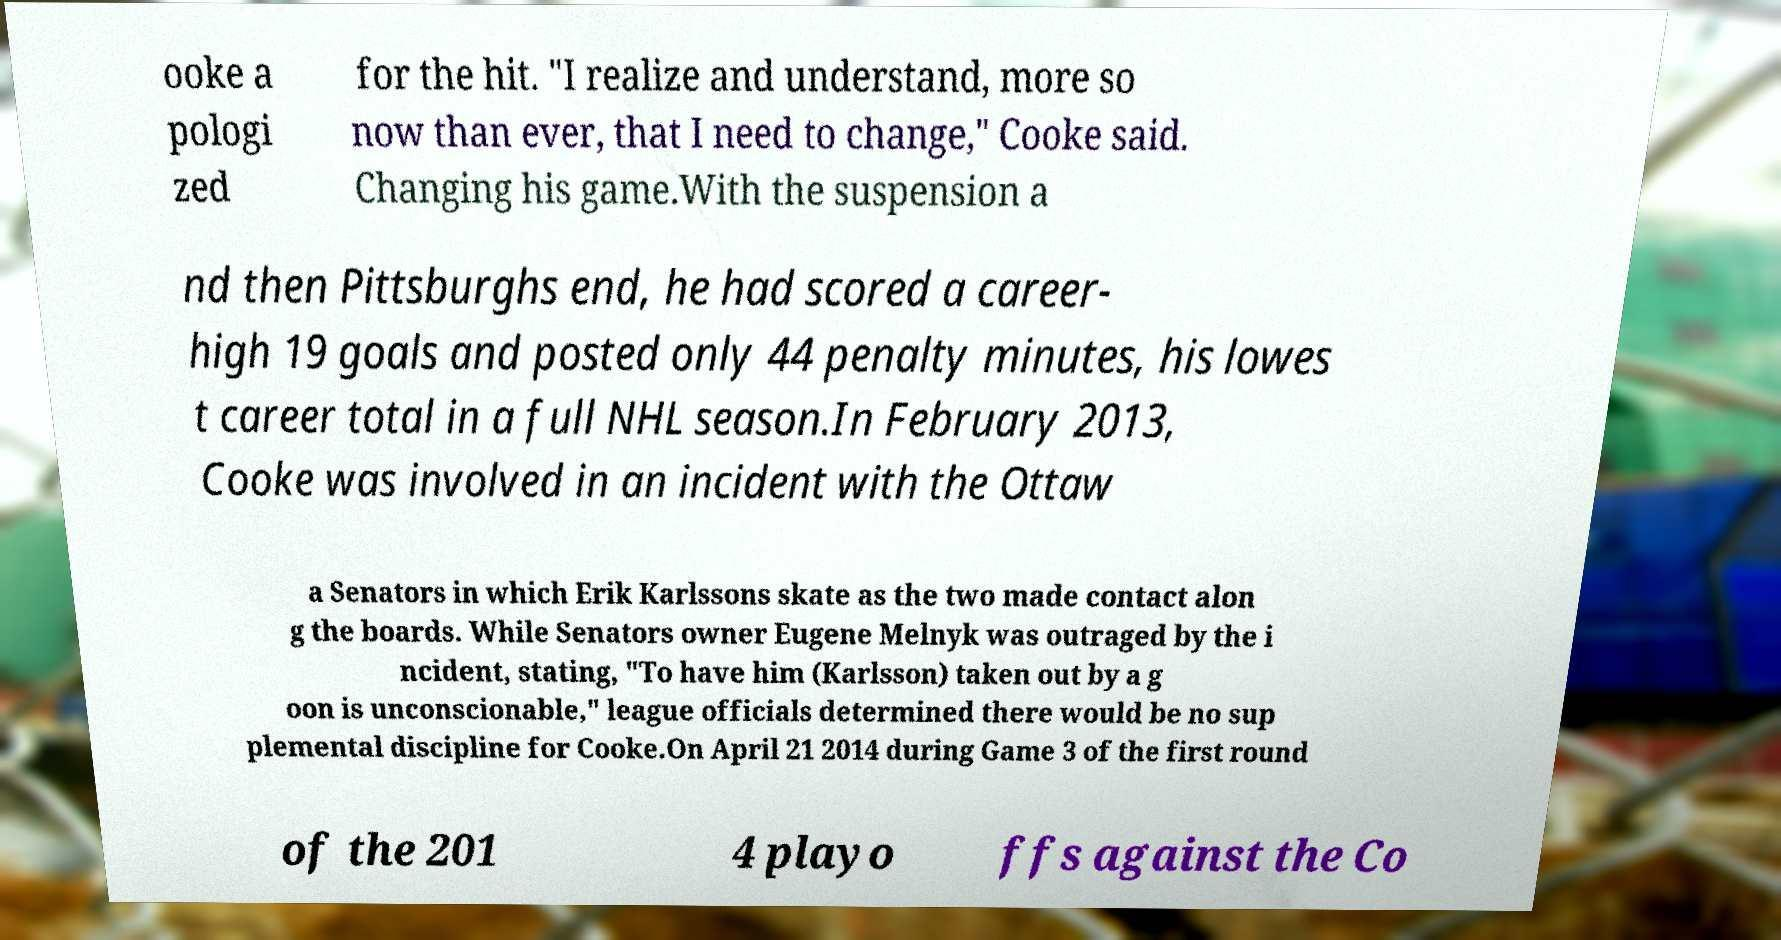Could you assist in decoding the text presented in this image and type it out clearly? ooke a pologi zed for the hit. "I realize and understand, more so now than ever, that I need to change," Cooke said. Changing his game.With the suspension a nd then Pittsburghs end, he had scored a career- high 19 goals and posted only 44 penalty minutes, his lowes t career total in a full NHL season.In February 2013, Cooke was involved in an incident with the Ottaw a Senators in which Erik Karlssons skate as the two made contact alon g the boards. While Senators owner Eugene Melnyk was outraged by the i ncident, stating, "To have him (Karlsson) taken out by a g oon is unconscionable," league officials determined there would be no sup plemental discipline for Cooke.On April 21 2014 during Game 3 of the first round of the 201 4 playo ffs against the Co 